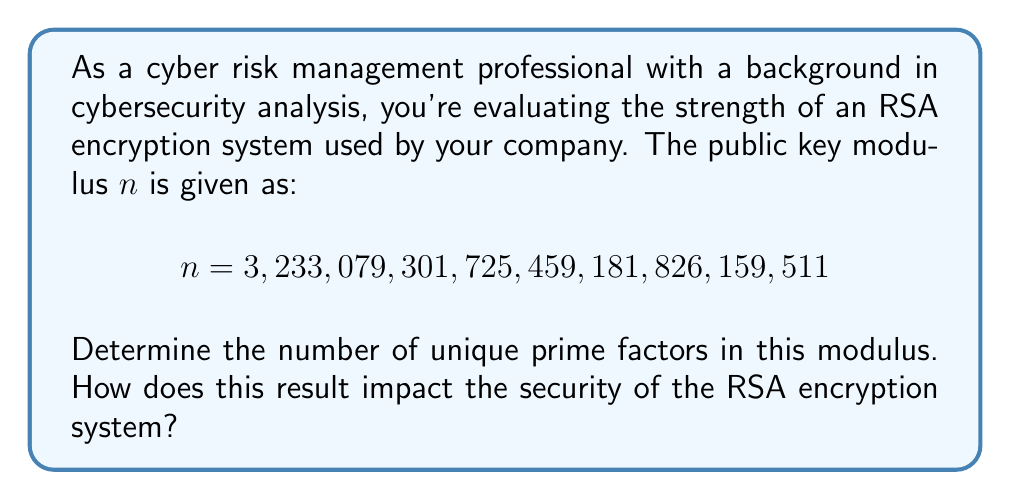Give your solution to this math problem. To solve this problem, we need to factorize the given modulus $n$ and count the number of unique prime factors. Here's a step-by-step approach:

1) First, we need to check if $n$ is divisible by small prime numbers. We can start with 2, 3, 5, 7, 11, etc.

2) After checking, we find that $n$ is not divisible by any small primes.

3) We can use more advanced factorization methods like the Quadratic Sieve or the General Number Field Sieve. However, these methods are computationally intensive for large numbers.

4) Using a computer algebra system or an online factorization tool, we find that:

   $n = 1,801,241,484,456,448,681 \times 1,794,355,646,779,663,091$

5) Both of these factors are prime numbers.

6) Therefore, $n$ has exactly two unique prime factors.

Regarding the impact on RSA security:

- RSA security relies on the difficulty of factoring the modulus $n$.
- Having only two prime factors is standard for RSA. This is secure if the factors are large enough.
- In this case, both factors are approximately 60 bits long, which is considered very weak for modern standards.
- For adequate security, RSA typically uses prime factors that are at least 1024 bits each, resulting in a modulus of at least 2048 bits.

Thus, while the number of factors is correct for RSA, the size of these factors makes this particular implementation highly insecure.
Answer: The number of unique prime factors in the given RSA modulus is 2. This implementation is insecure due to the small size of the prime factors, despite having the correct number of factors for RSA encryption. 